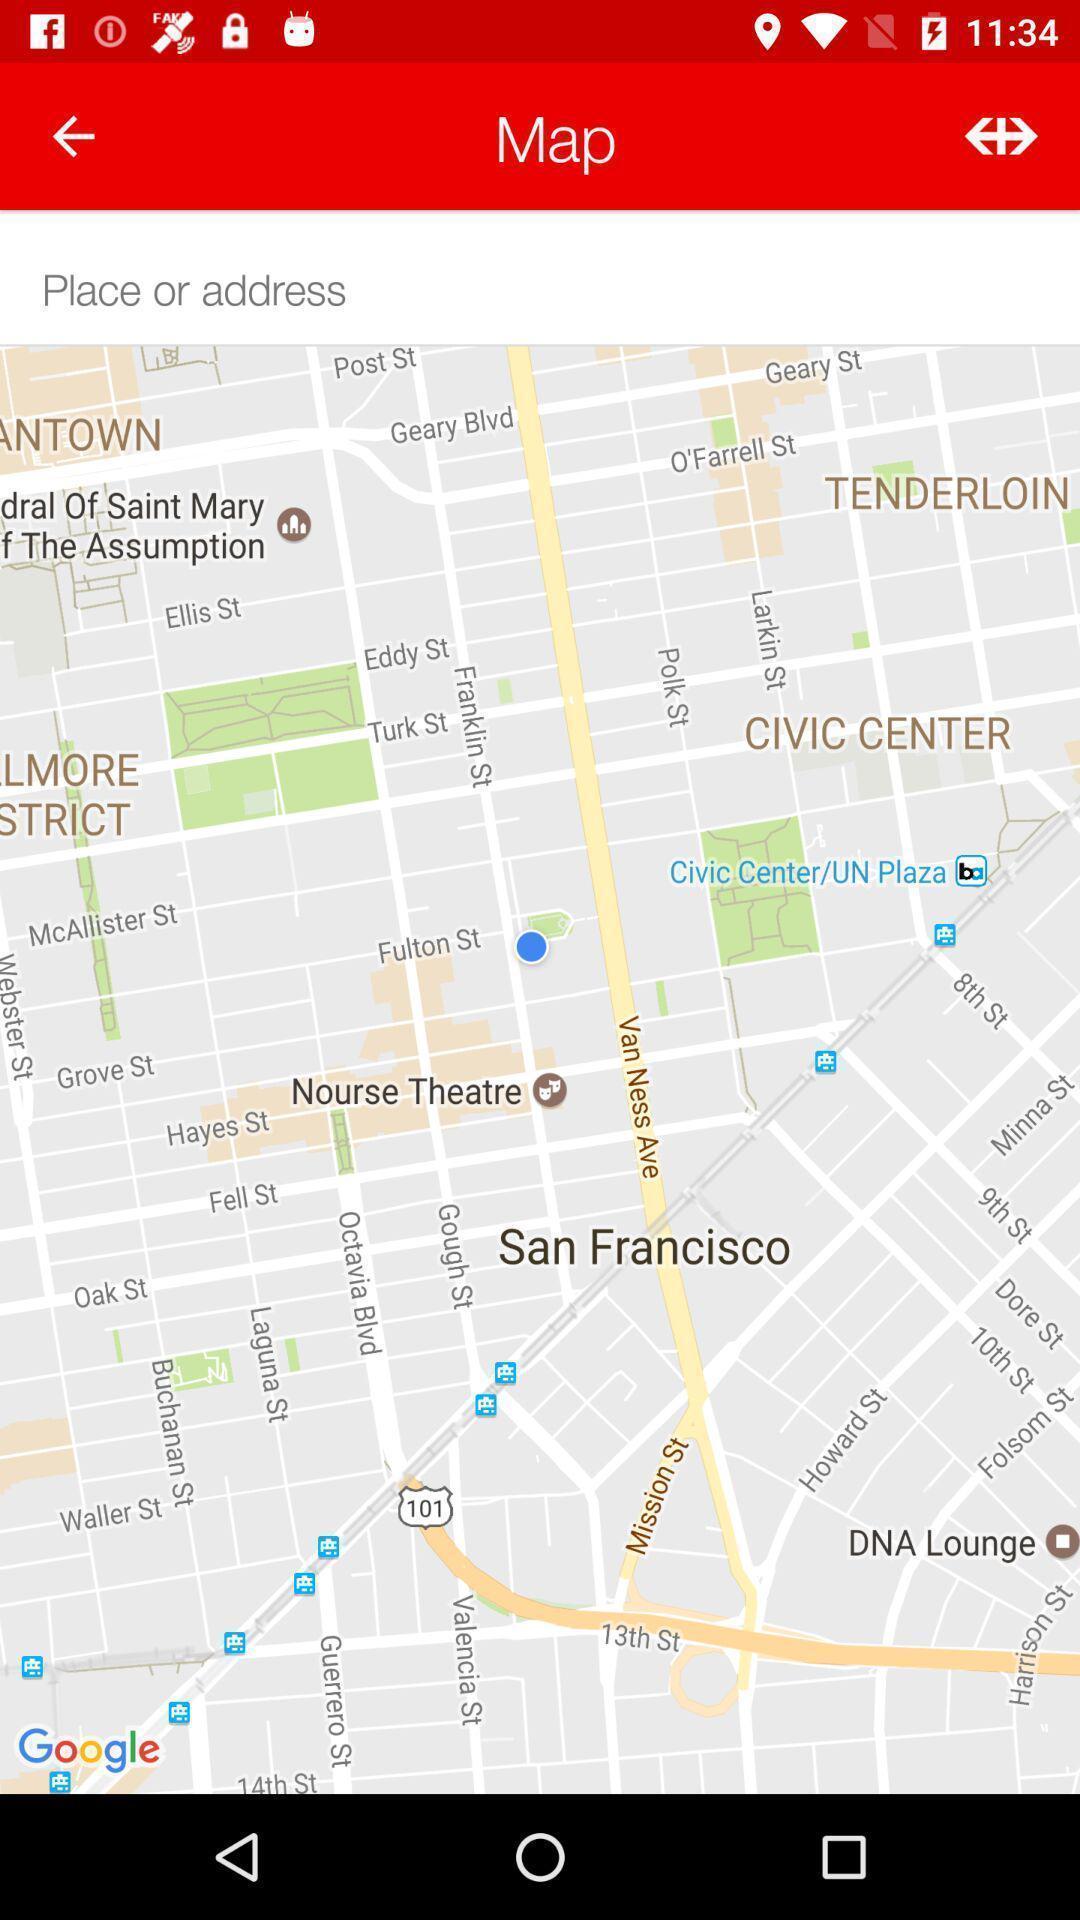Provide a textual representation of this image. Page showing variety of places from map. 